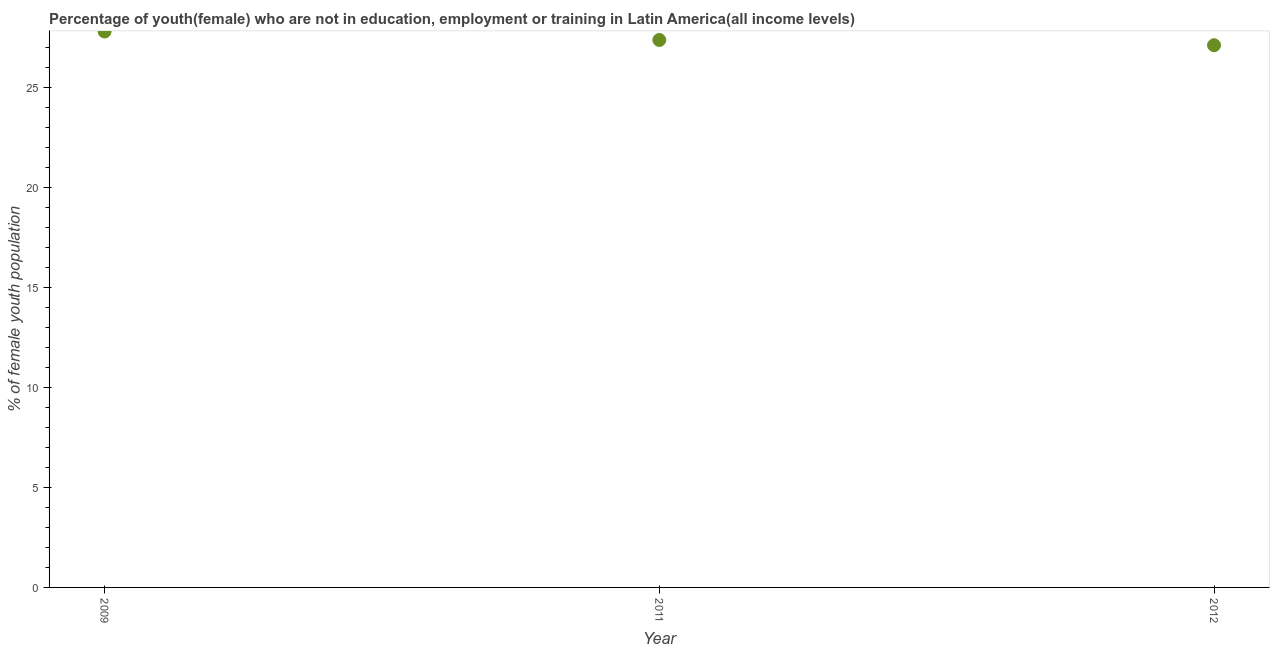What is the unemployed female youth population in 2009?
Your response must be concise. 27.8. Across all years, what is the maximum unemployed female youth population?
Provide a short and direct response. 27.8. Across all years, what is the minimum unemployed female youth population?
Offer a terse response. 27.11. In which year was the unemployed female youth population minimum?
Provide a succinct answer. 2012. What is the sum of the unemployed female youth population?
Your answer should be very brief. 82.28. What is the difference between the unemployed female youth population in 2011 and 2012?
Your answer should be compact. 0.26. What is the average unemployed female youth population per year?
Your response must be concise. 27.43. What is the median unemployed female youth population?
Give a very brief answer. 27.37. In how many years, is the unemployed female youth population greater than 4 %?
Offer a very short reply. 3. What is the ratio of the unemployed female youth population in 2009 to that in 2011?
Your answer should be compact. 1.02. What is the difference between the highest and the second highest unemployed female youth population?
Offer a terse response. 0.42. Is the sum of the unemployed female youth population in 2009 and 2011 greater than the maximum unemployed female youth population across all years?
Give a very brief answer. Yes. What is the difference between the highest and the lowest unemployed female youth population?
Your answer should be very brief. 0.69. How many dotlines are there?
Provide a short and direct response. 1. How many years are there in the graph?
Your answer should be very brief. 3. What is the difference between two consecutive major ticks on the Y-axis?
Your response must be concise. 5. Does the graph contain any zero values?
Your answer should be very brief. No. Does the graph contain grids?
Make the answer very short. No. What is the title of the graph?
Make the answer very short. Percentage of youth(female) who are not in education, employment or training in Latin America(all income levels). What is the label or title of the Y-axis?
Make the answer very short. % of female youth population. What is the % of female youth population in 2009?
Offer a terse response. 27.8. What is the % of female youth population in 2011?
Your answer should be very brief. 27.37. What is the % of female youth population in 2012?
Your answer should be very brief. 27.11. What is the difference between the % of female youth population in 2009 and 2011?
Give a very brief answer. 0.42. What is the difference between the % of female youth population in 2009 and 2012?
Offer a terse response. 0.69. What is the difference between the % of female youth population in 2011 and 2012?
Provide a succinct answer. 0.26. What is the ratio of the % of female youth population in 2009 to that in 2011?
Keep it short and to the point. 1.01. What is the ratio of the % of female youth population in 2009 to that in 2012?
Provide a short and direct response. 1.02. What is the ratio of the % of female youth population in 2011 to that in 2012?
Offer a terse response. 1.01. 